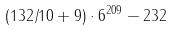Convert formula to latex. <formula><loc_0><loc_0><loc_500><loc_500>( 1 3 2 / 1 0 + 9 ) \cdot 6 ^ { 2 0 9 } - 2 3 2</formula> 